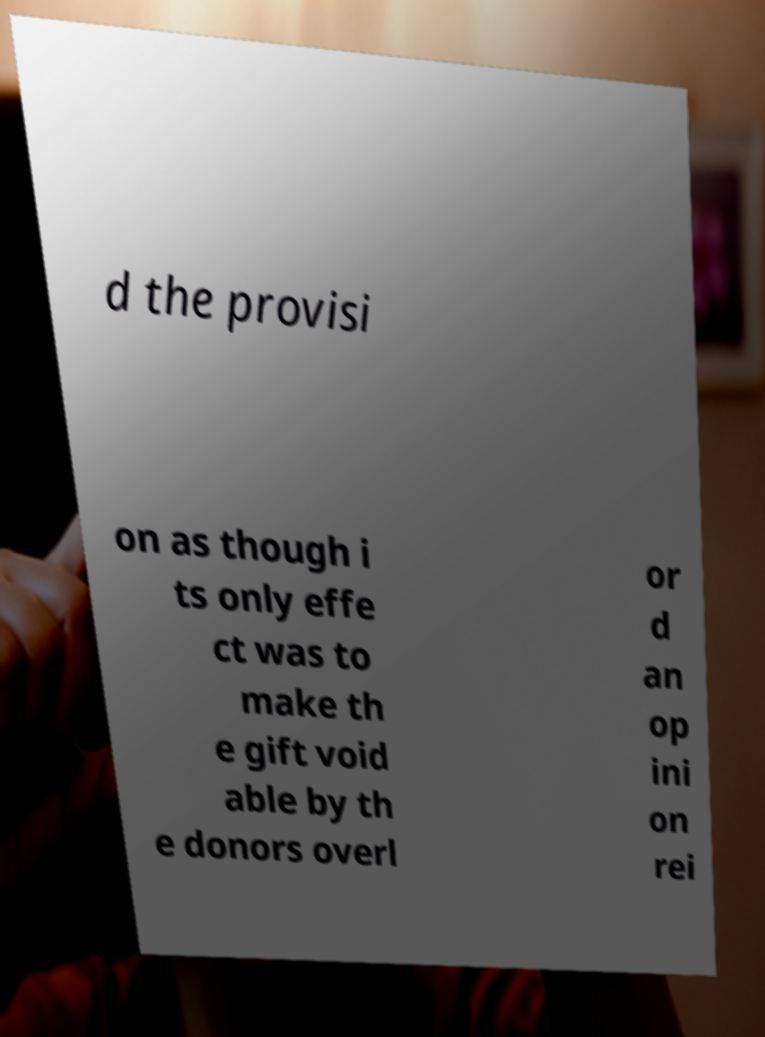Could you extract and type out the text from this image? d the provisi on as though i ts only effe ct was to make th e gift void able by th e donors overl or d an op ini on rei 